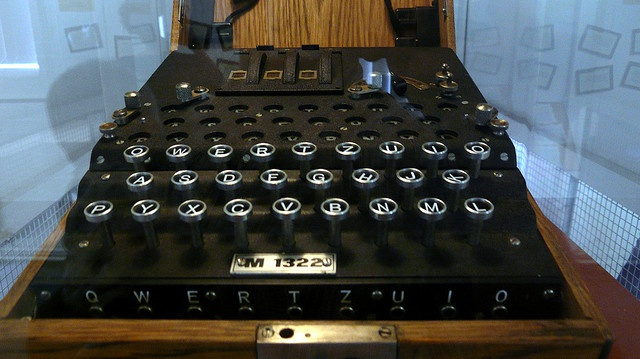Describe the objects in this image and their specific colors. I can see various objects in this image with different colors. 